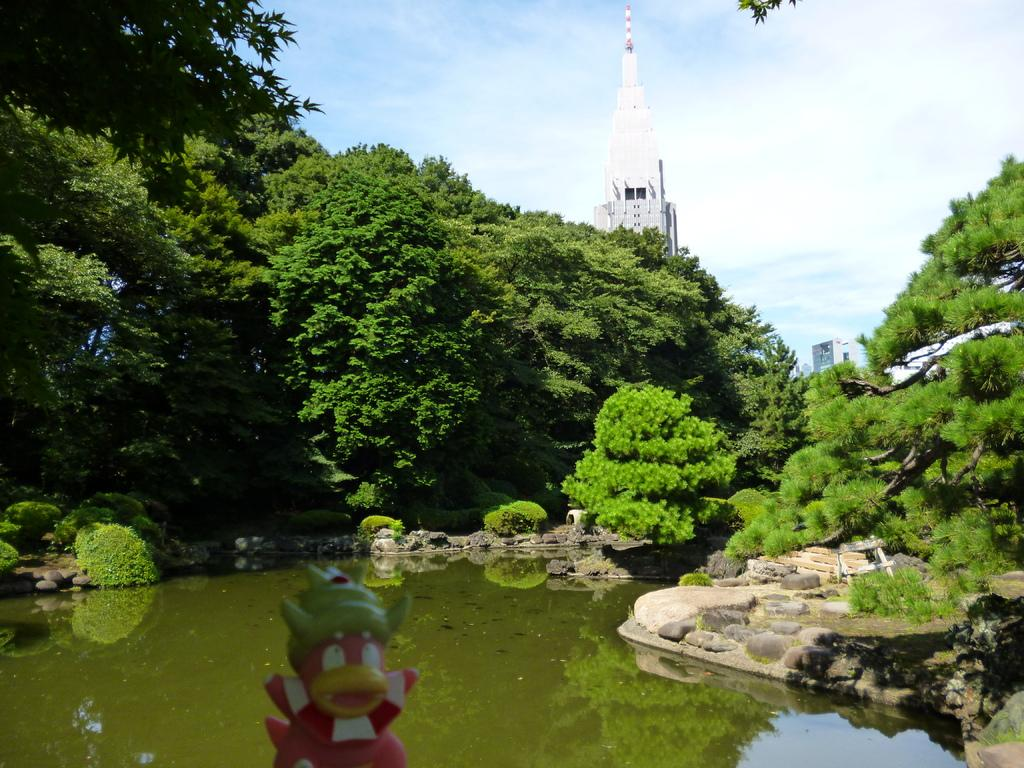What is the primary element visible in the image? There is water in the image. What can be found at the bottom of the image? There are rocks at the bottom side of the image. What type of vegetation is present in the image? There are trees in the center of the image. What structure can be seen in the background of the image? There is a tower in the background area of the image. Can you see any jellyfish in the water in the image? There are no jellyfish visible in the water in the image. What type of glue is being used to attach the rocks to the trees in the image? There is no glue or attachment of rocks to trees in the image; the rocks and trees are separate elements. 